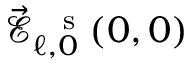Convert formula to latex. <formula><loc_0><loc_0><loc_500><loc_500>\vec { \mathcal { E } } _ { \ell , 0 } ^ { \, s } ( 0 , 0 )</formula> 